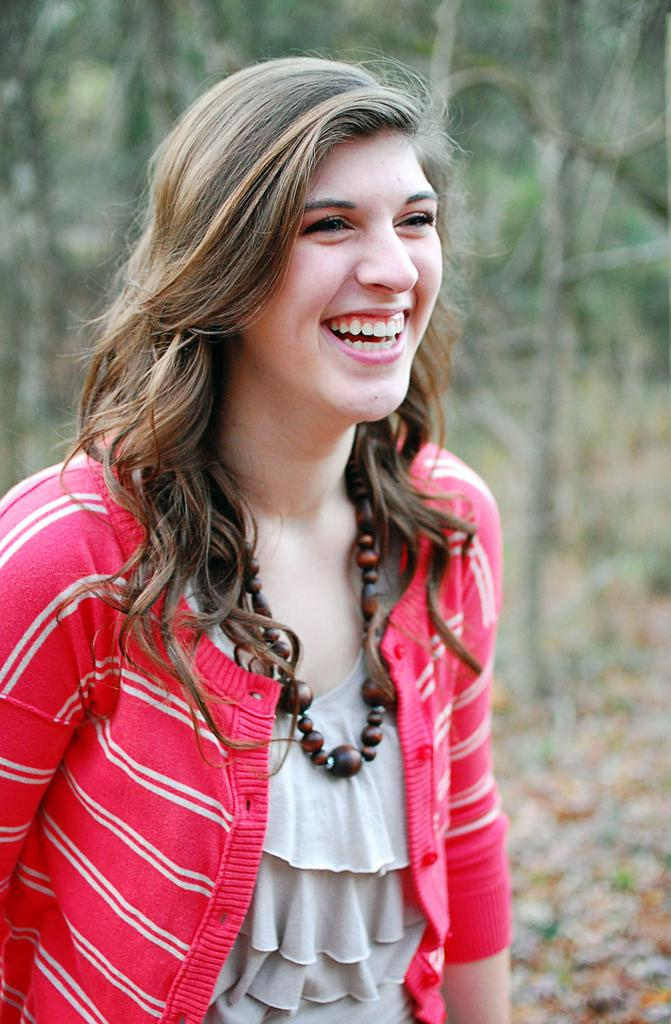Who is the main subject in the image? There is a woman in the image. Where is the woman positioned in the image? The woman is standing in the middle of the image. What expression does the woman have? The woman is smiling. What can be seen in the background of the image? There are trees visible behind the woman. What type of grape is the woman holding in the image? There is no grape present in the image; the woman is not holding anything. How does the woman say good-bye in the image? The image does not show the woman saying good-bye or performing any specific action. 